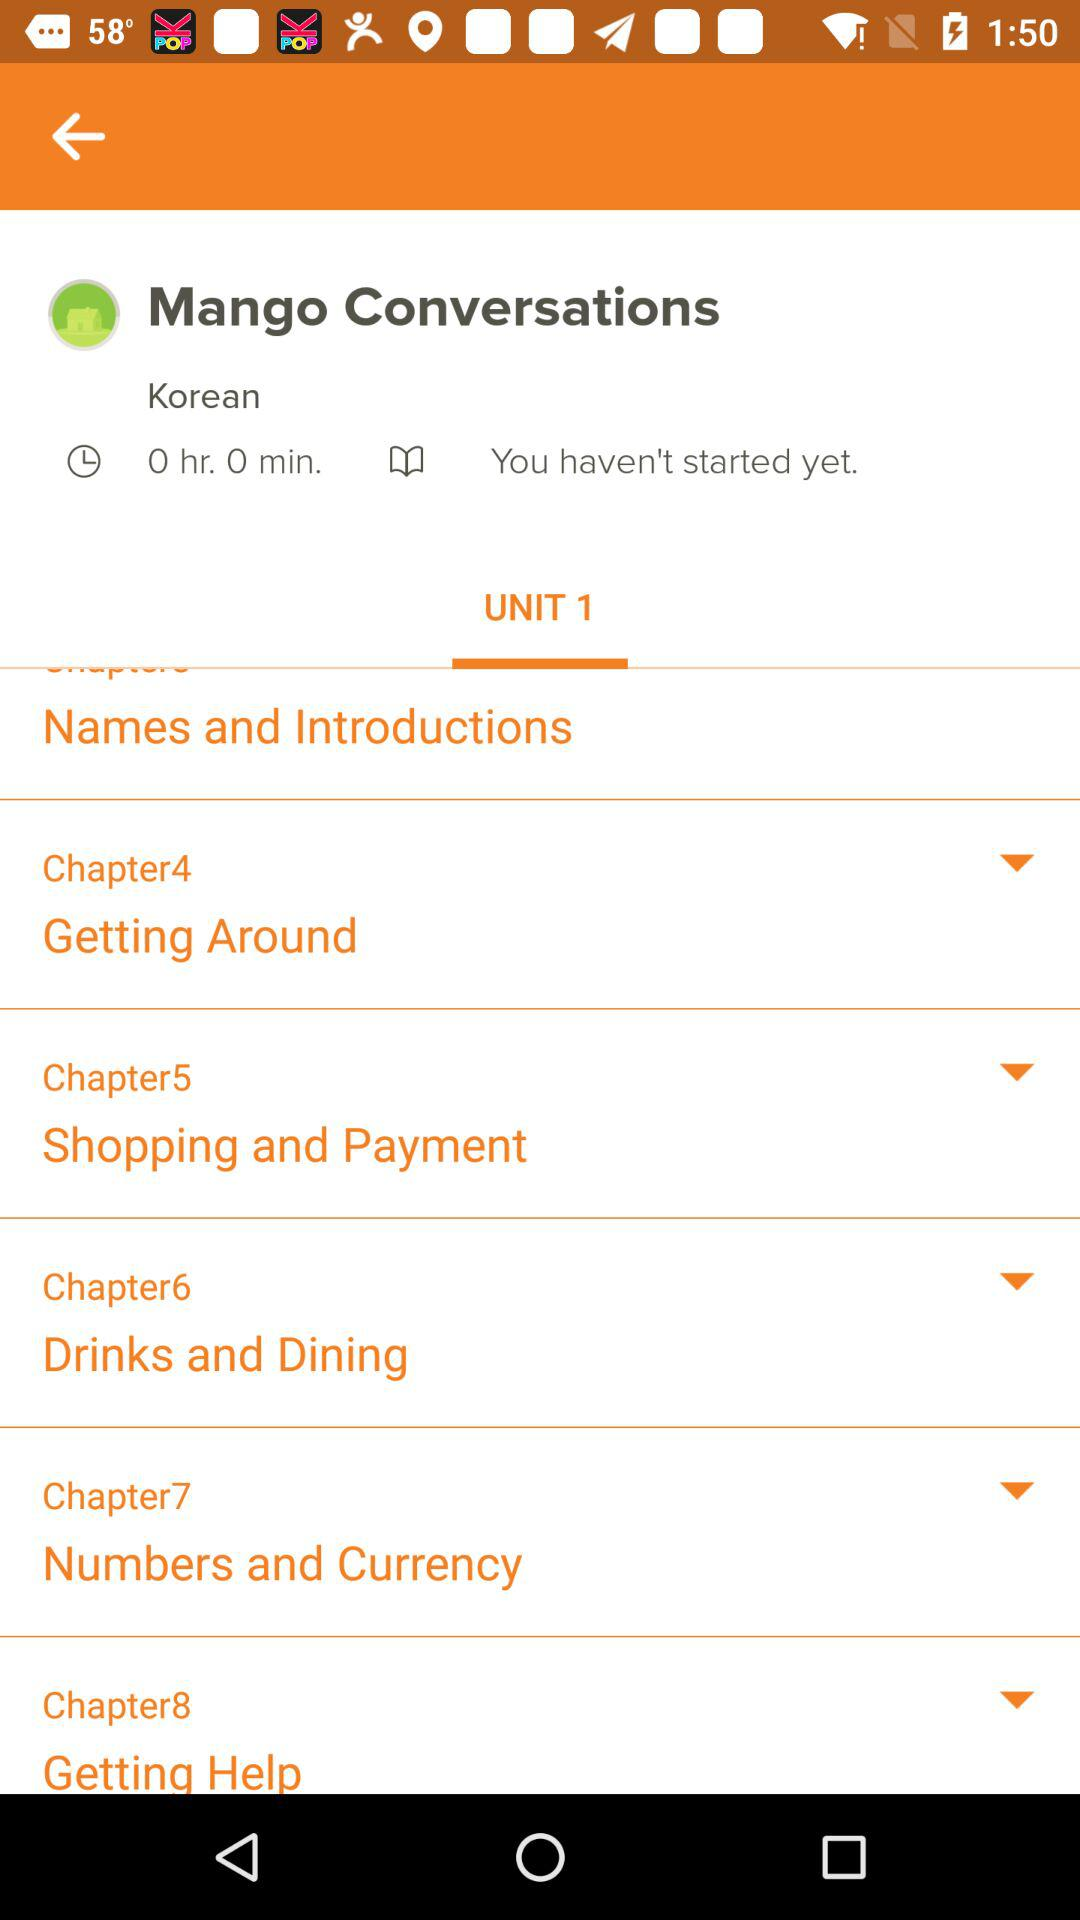What is the title of chapter 2 in unit 2?
When the provided information is insufficient, respond with <no answer>. <no answer> 